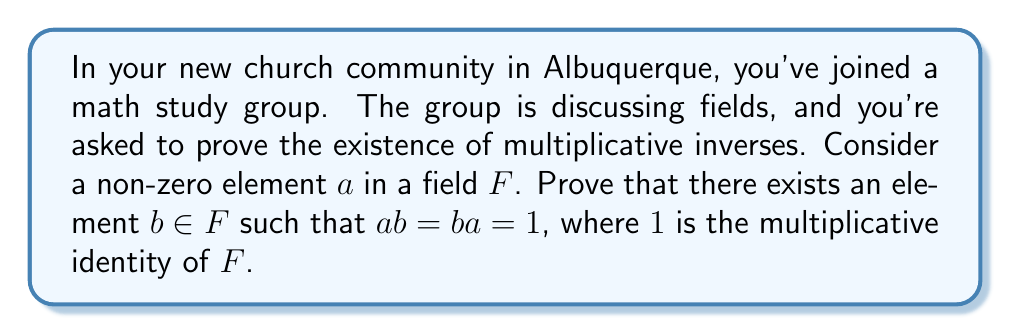Provide a solution to this math problem. Let's approach this proof step-by-step:

1) First, recall that a field $F$ is a set with two operations (addition and multiplication) that satisfy certain axioms, including the existence of additive and multiplicative identities.

2) We start by considering the set $S = \{ax : x \in F\}$. This is the set of all elements in $F$ multiplied by $a$.

3) We know that $0 \notin S$ because $a \neq 0$ (given in the question) and $F$ has no zero divisors (a property of fields).

4) Now, we can use the fact that in a field, the multiplicative operation is distributive over addition. So for any $y, z \in F$:

   $a(y+z) = ay + az$

5) This means that $S$ is closed under addition: if $ay, az \in S$, then $a(y+z) = ay + az \in S$.

6) $S$ is also closed under additive inverses: if $ay \in S$, then $a(-y) = -(ay) \in S$.

7) These properties, along with the associativity and commutativity of addition in $F$, make $S$ a subgroup of the additive group of $F$.

8) Since $S$ is a non-empty subgroup (it contains at least $a$) of the finite additive group of $F$, and $S \neq \{0\}$, we can conclude that $S = F$.

9) This means that there exists an element $b \in F$ such that $ab = 1$, where $1$ is the multiplicative identity of $F$.

10) To show that $ba = 1$ as well, we can multiply both sides of $ab = 1$ by $b$:

    $b(ab) = b1 = b$

    $(ba)b = b$

    Since $F$ has no zero divisors and $b \neq 0$, we can conclude that $ba = 1$.

Therefore, we have proved the existence of a multiplicative inverse $b$ for any non-zero element $a$ in the field $F$, such that $ab = ba = 1$.
Answer: For any non-zero element $a$ in a field $F$, there exists an element $b \in F$ such that $ab = ba = 1$, where $1$ is the multiplicative identity of $F$. This $b$ is the multiplicative inverse of $a$. 